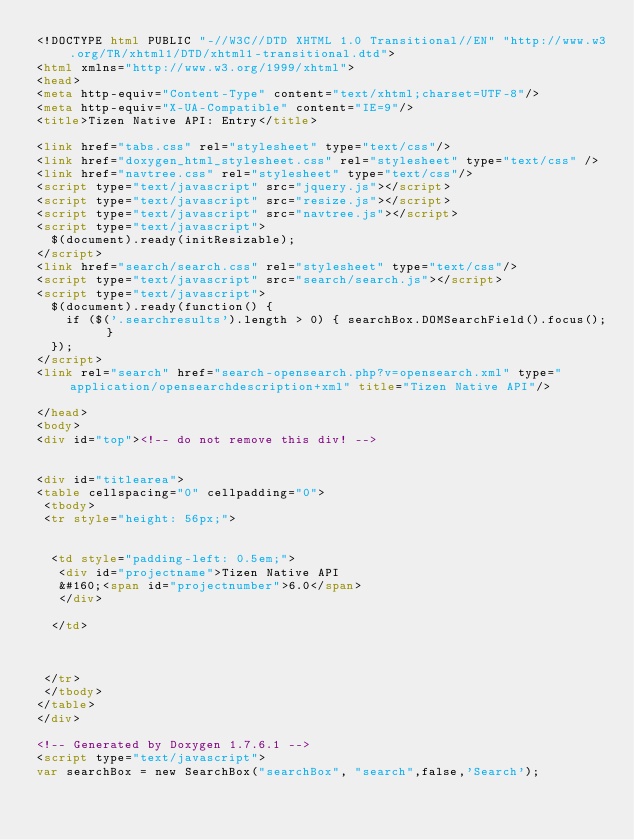Convert code to text. <code><loc_0><loc_0><loc_500><loc_500><_HTML_><!DOCTYPE html PUBLIC "-//W3C//DTD XHTML 1.0 Transitional//EN" "http://www.w3.org/TR/xhtml1/DTD/xhtml1-transitional.dtd">
<html xmlns="http://www.w3.org/1999/xhtml">
<head>
<meta http-equiv="Content-Type" content="text/xhtml;charset=UTF-8"/>
<meta http-equiv="X-UA-Compatible" content="IE=9"/>
<title>Tizen Native API: Entry</title>

<link href="tabs.css" rel="stylesheet" type="text/css"/>
<link href="doxygen_html_stylesheet.css" rel="stylesheet" type="text/css" />
<link href="navtree.css" rel="stylesheet" type="text/css"/>
<script type="text/javascript" src="jquery.js"></script>
<script type="text/javascript" src="resize.js"></script>
<script type="text/javascript" src="navtree.js"></script>
<script type="text/javascript">
  $(document).ready(initResizable);
</script>
<link href="search/search.css" rel="stylesheet" type="text/css"/>
<script type="text/javascript" src="search/search.js"></script>
<script type="text/javascript">
  $(document).ready(function() {
    if ($('.searchresults').length > 0) { searchBox.DOMSearchField().focus(); }
  });
</script>
<link rel="search" href="search-opensearch.php?v=opensearch.xml" type="application/opensearchdescription+xml" title="Tizen Native API"/>

</head>
<body>
<div id="top"><!-- do not remove this div! -->


<div id="titlearea">
<table cellspacing="0" cellpadding="0">
 <tbody>
 <tr style="height: 56px;">
  
  
  <td style="padding-left: 0.5em;">
   <div id="projectname">Tizen Native API
   &#160;<span id="projectnumber">6.0</span>
   </div>
   
  </td>
  
  
  
 </tr>
 </tbody>
</table>
</div>

<!-- Generated by Doxygen 1.7.6.1 -->
<script type="text/javascript">
var searchBox = new SearchBox("searchBox", "search",false,'Search');</code> 